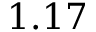Convert formula to latex. <formula><loc_0><loc_0><loc_500><loc_500>1 . 1 7</formula> 